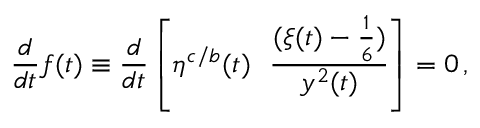<formula> <loc_0><loc_0><loc_500><loc_500>{ \frac { d } { d t } } f ( t ) \equiv \frac { d } { d t } \left [ \eta ^ { c / b } ( t ) { \frac { ( \xi ( t ) - { \frac { 1 } { 6 } } ) } { y ^ { 2 } ( t ) } } \right ] = 0 \, ,</formula> 